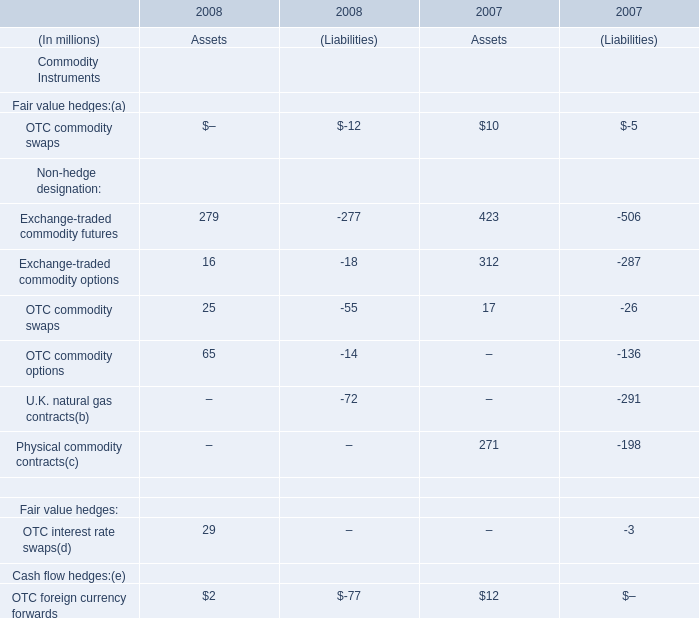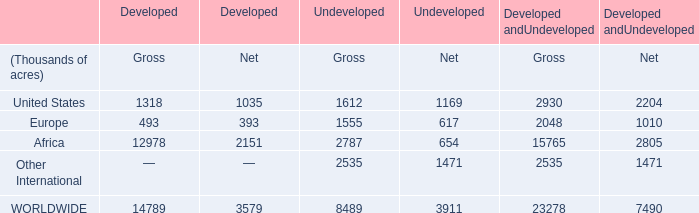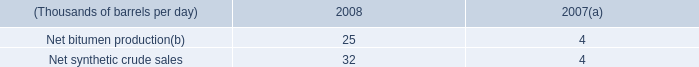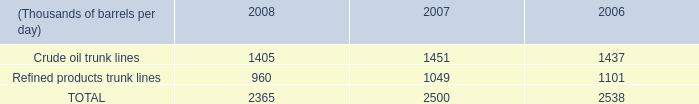What is the total amount of WORLDWIDE of Undeveloped Net, and Refined products trunk lines of 2007 ? 
Computations: (3911.0 + 1049.0)
Answer: 4960.0. 